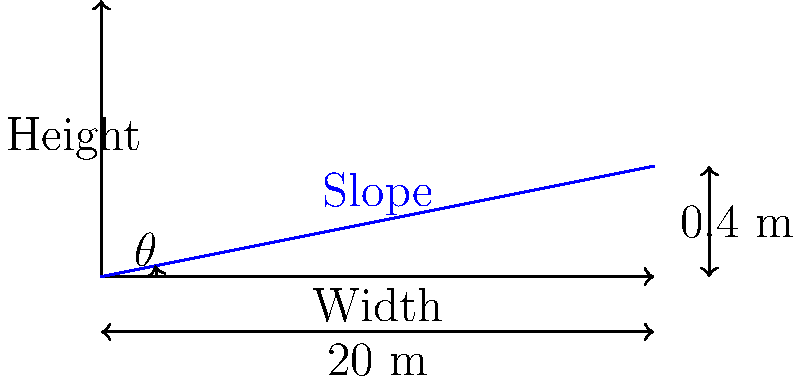As you're rushing to retrieve those sensitive documents, you notice the street's unique design. The city engineer mentions that the street has a width of 20 meters and a height difference of 0.4 meters from one side to the other for proper water drainage. What is the optimal slope angle $\theta$ (in degrees) for this street to ensure effective water runoff while maintaining safe driving conditions? To find the optimal slope angle $\theta$, we need to follow these steps:

1. Identify the given information:
   - Street width = 20 meters
   - Height difference = 0.4 meters

2. Calculate the slope as a ratio:
   Slope = Height difference / Width
   Slope = 0.4 m / 20 m = 0.02 or 2%

3. To find the angle $\theta$, we need to use the inverse tangent function (arctan or $\tan^{-1}$):
   $\theta = \tan^{-1}(\text{Slope})$

4. Calculate the angle:
   $\theta = \tan^{-1}(0.02)$

5. Convert the result to degrees:
   $\theta = \tan^{-1}(0.02) \times (180/\pi)$ (since $\tan^{-1}$ returns the angle in radians)

6. Solve:
   $\theta \approx 1.15°$

This slope angle of approximately 1.15° provides an optimal balance between effective water drainage and safe driving conditions. It allows water to flow off the street surface while not being too steep for vehicles.
Answer: $\theta \approx 1.15°$ 